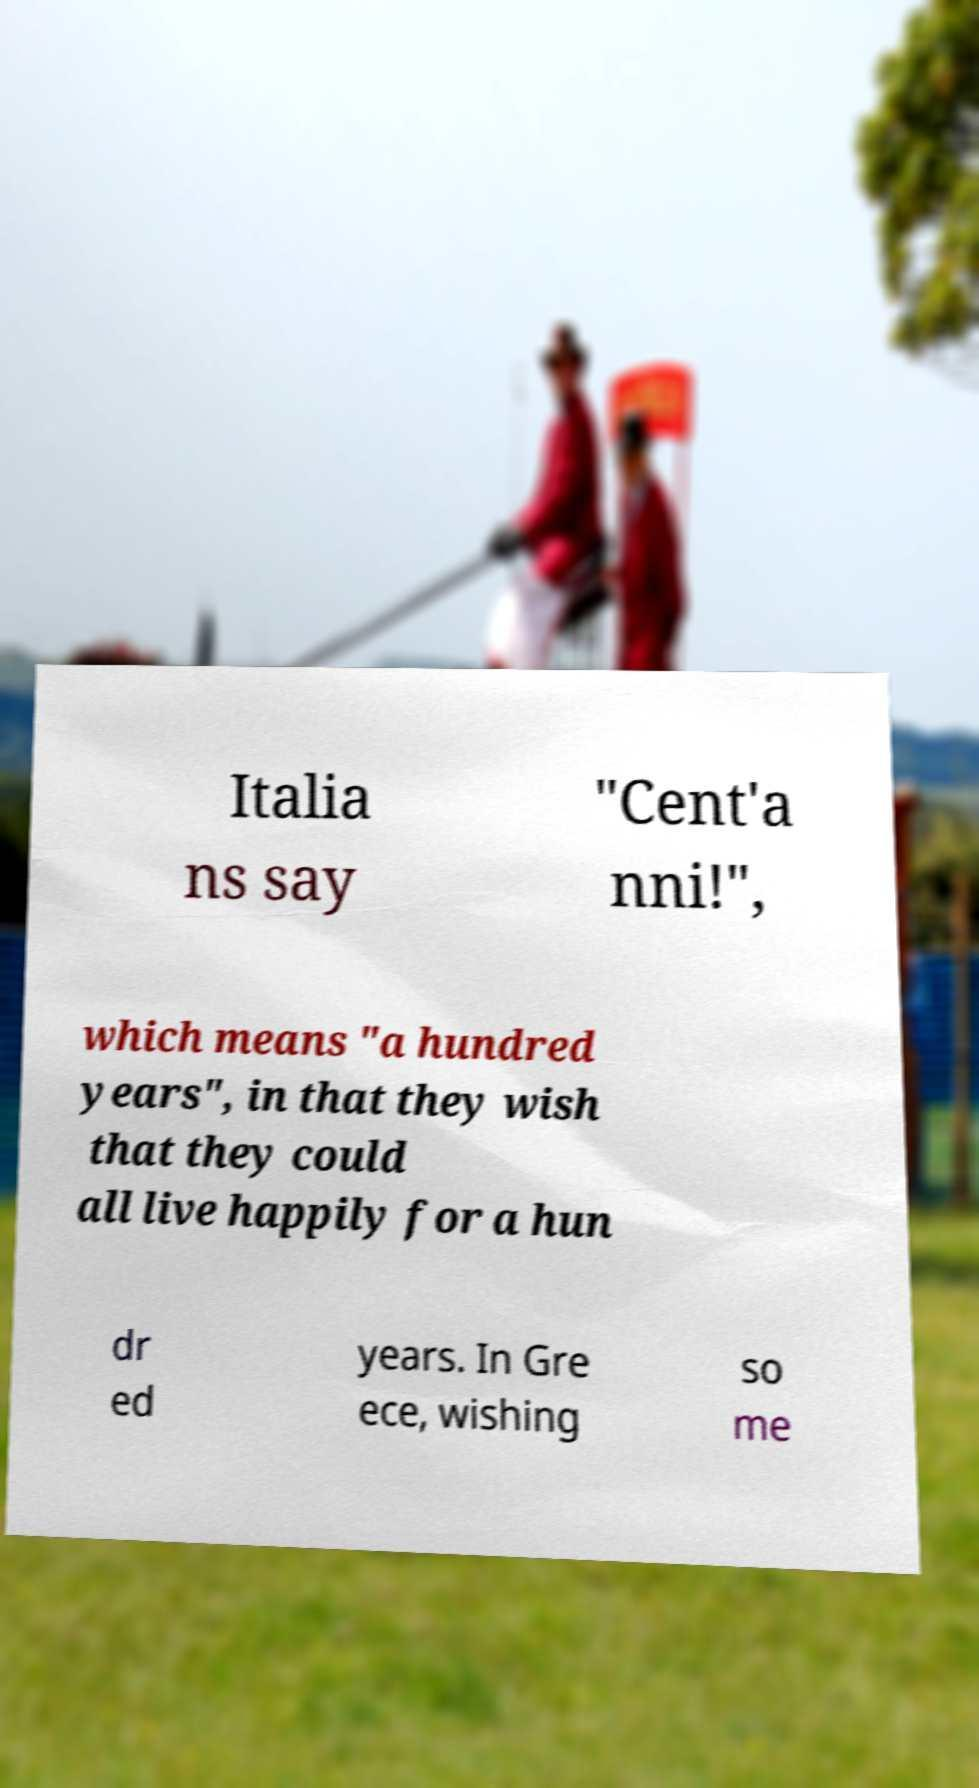What messages or text are displayed in this image? I need them in a readable, typed format. Italia ns say "Cent'a nni!", which means "a hundred years", in that they wish that they could all live happily for a hun dr ed years. In Gre ece, wishing so me 